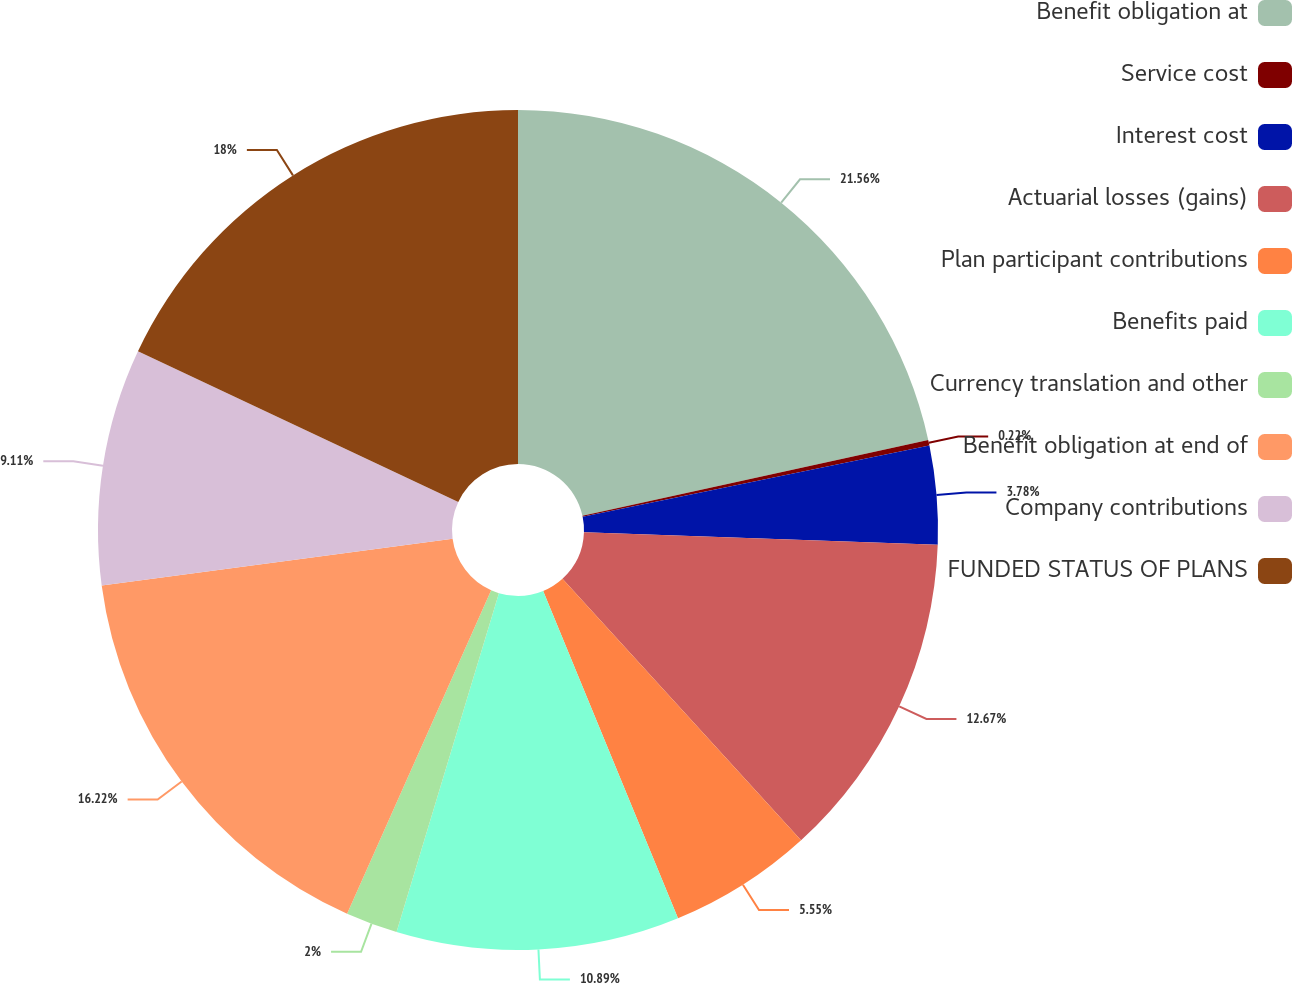Convert chart. <chart><loc_0><loc_0><loc_500><loc_500><pie_chart><fcel>Benefit obligation at<fcel>Service cost<fcel>Interest cost<fcel>Actuarial losses (gains)<fcel>Plan participant contributions<fcel>Benefits paid<fcel>Currency translation and other<fcel>Benefit obligation at end of<fcel>Company contributions<fcel>FUNDED STATUS OF PLANS<nl><fcel>21.56%<fcel>0.22%<fcel>3.78%<fcel>12.67%<fcel>5.55%<fcel>10.89%<fcel>2.0%<fcel>16.22%<fcel>9.11%<fcel>18.0%<nl></chart> 